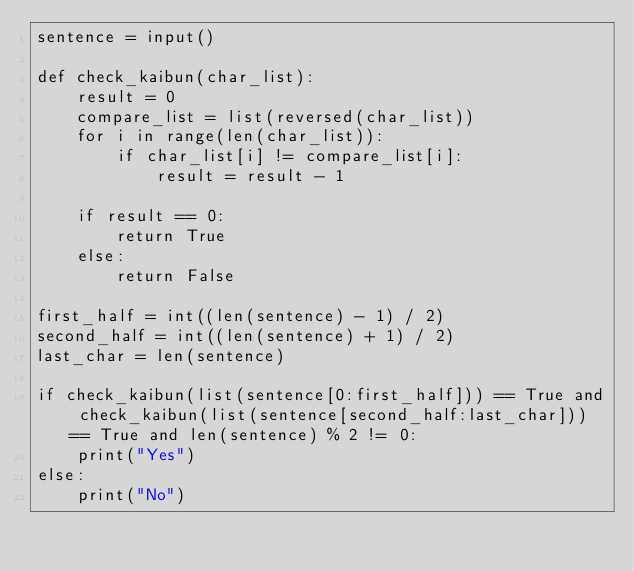<code> <loc_0><loc_0><loc_500><loc_500><_Python_>sentence = input()

def check_kaibun(char_list):
    result = 0
    compare_list = list(reversed(char_list))
    for i in range(len(char_list)):
        if char_list[i] != compare_list[i]:
            result = result - 1

    if result == 0:
        return True
    else:
        return False

first_half = int((len(sentence) - 1) / 2)
second_half = int((len(sentence) + 1) / 2)
last_char = len(sentence)

if check_kaibun(list(sentence[0:first_half])) == True and check_kaibun(list(sentence[second_half:last_char])) == True and len(sentence) % 2 != 0:
    print("Yes")
else:
    print("No")</code> 